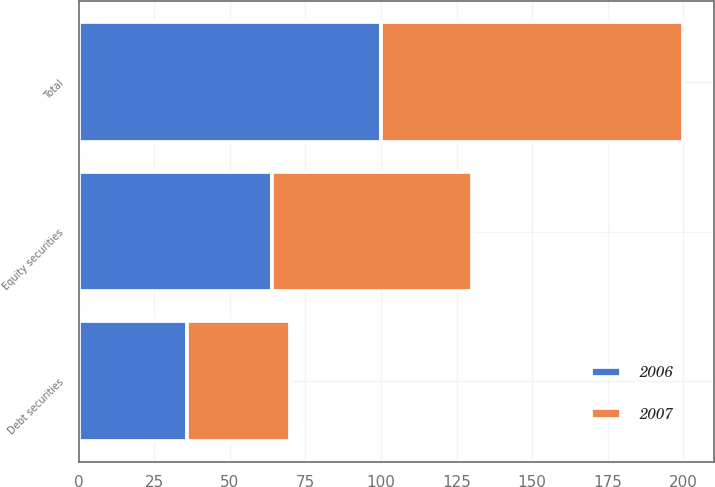Convert chart. <chart><loc_0><loc_0><loc_500><loc_500><stacked_bar_chart><ecel><fcel>Equity securities<fcel>Debt securities<fcel>Total<nl><fcel>2007<fcel>66<fcel>34<fcel>100<nl><fcel>2006<fcel>64<fcel>36<fcel>100<nl></chart> 